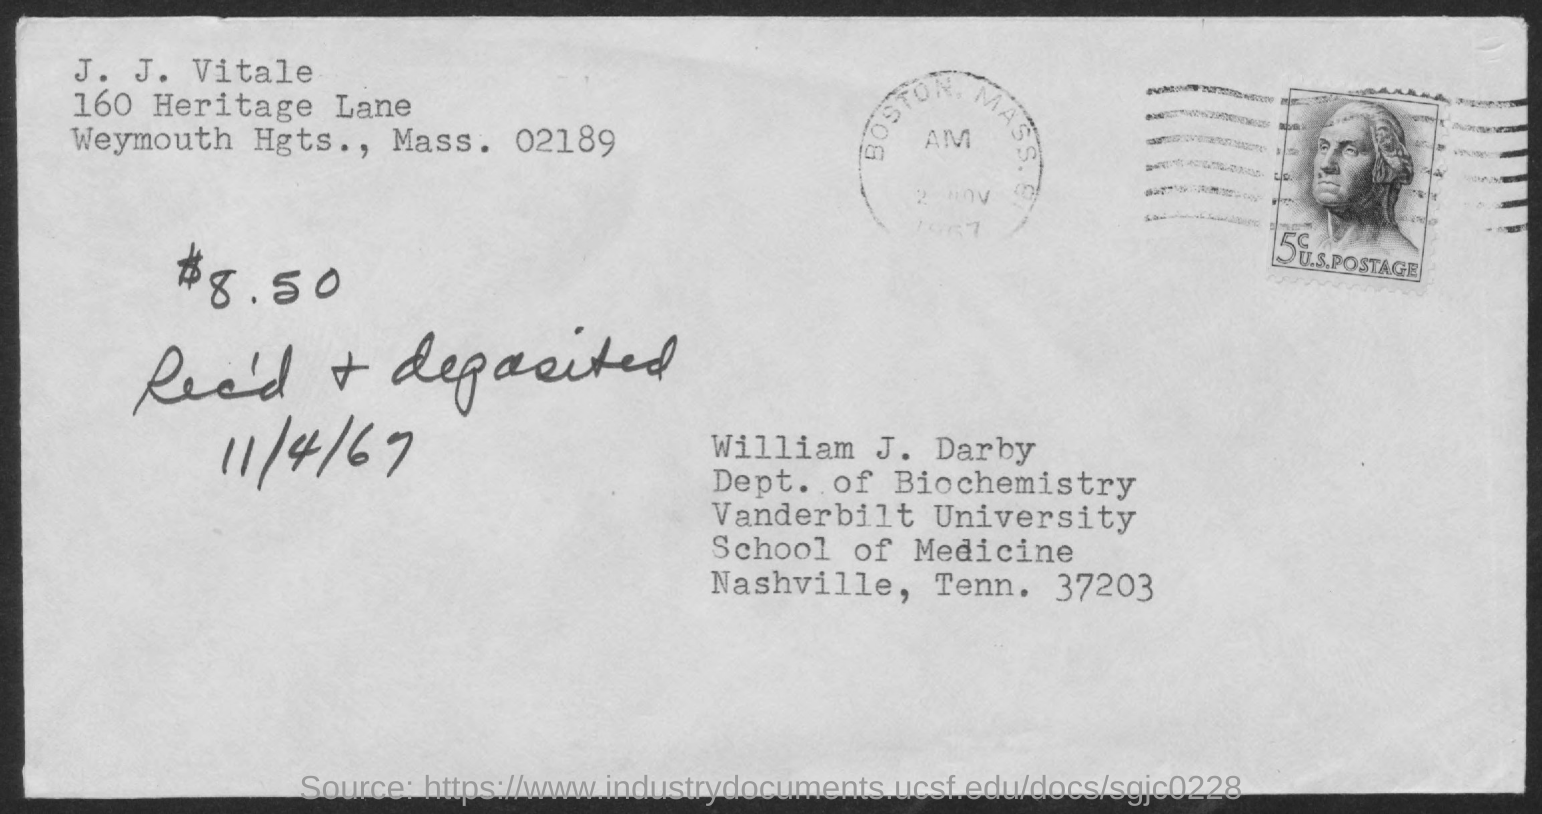Draw attention to some important aspects in this diagram. The person written in the top left corner is named J. J. Vitale. 